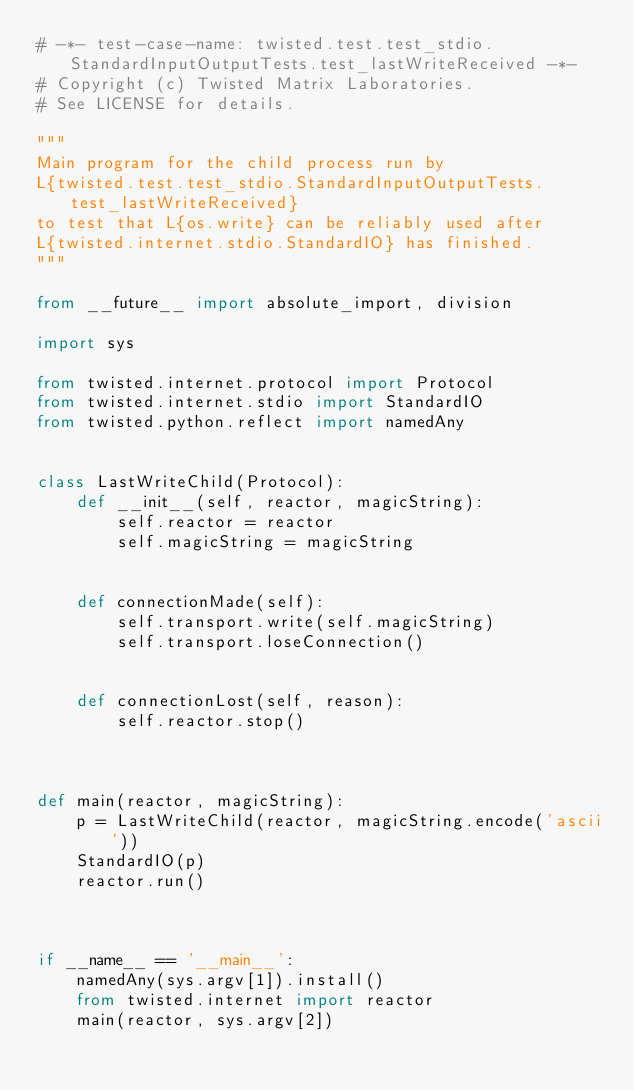Convert code to text. <code><loc_0><loc_0><loc_500><loc_500><_Python_># -*- test-case-name: twisted.test.test_stdio.StandardInputOutputTests.test_lastWriteReceived -*-
# Copyright (c) Twisted Matrix Laboratories.
# See LICENSE for details.

"""
Main program for the child process run by
L{twisted.test.test_stdio.StandardInputOutputTests.test_lastWriteReceived}
to test that L{os.write} can be reliably used after
L{twisted.internet.stdio.StandardIO} has finished.
"""

from __future__ import absolute_import, division

import sys

from twisted.internet.protocol import Protocol
from twisted.internet.stdio import StandardIO
from twisted.python.reflect import namedAny


class LastWriteChild(Protocol):
    def __init__(self, reactor, magicString):
        self.reactor = reactor
        self.magicString = magicString


    def connectionMade(self):
        self.transport.write(self.magicString)
        self.transport.loseConnection()


    def connectionLost(self, reason):
        self.reactor.stop()



def main(reactor, magicString):
    p = LastWriteChild(reactor, magicString.encode('ascii'))
    StandardIO(p)
    reactor.run()



if __name__ == '__main__':
    namedAny(sys.argv[1]).install()
    from twisted.internet import reactor
    main(reactor, sys.argv[2])
</code> 